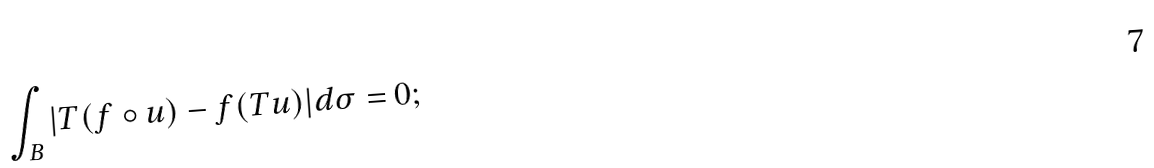Convert formula to latex. <formula><loc_0><loc_0><loc_500><loc_500>\int _ { B } | T ( f \circ u ) - f ( T u ) | d \sigma = 0 ;</formula> 